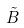Convert formula to latex. <formula><loc_0><loc_0><loc_500><loc_500>\tilde { B }</formula> 